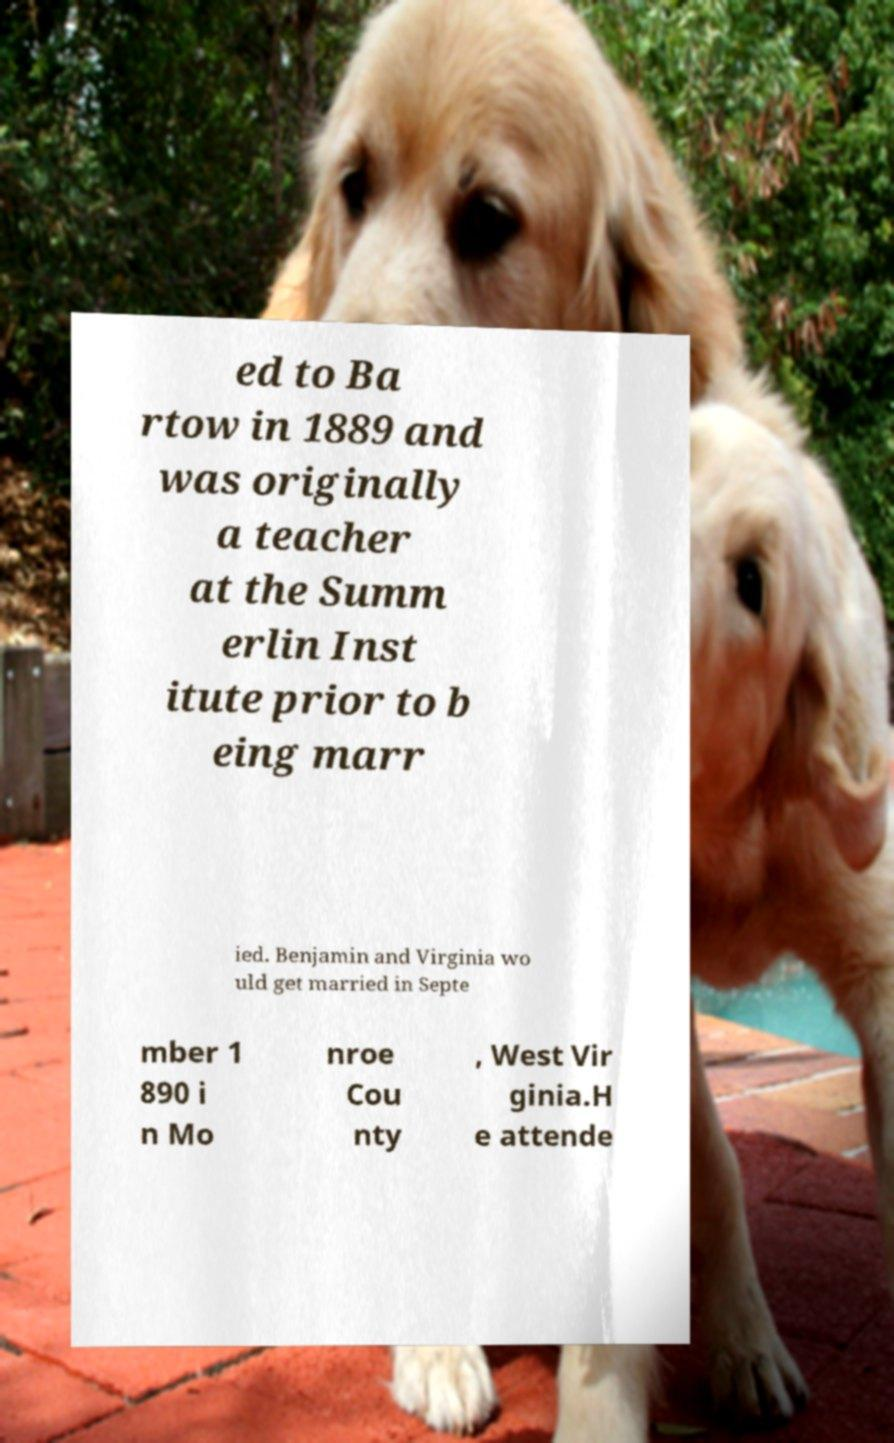Could you extract and type out the text from this image? ed to Ba rtow in 1889 and was originally a teacher at the Summ erlin Inst itute prior to b eing marr ied. Benjamin and Virginia wo uld get married in Septe mber 1 890 i n Mo nroe Cou nty , West Vir ginia.H e attende 